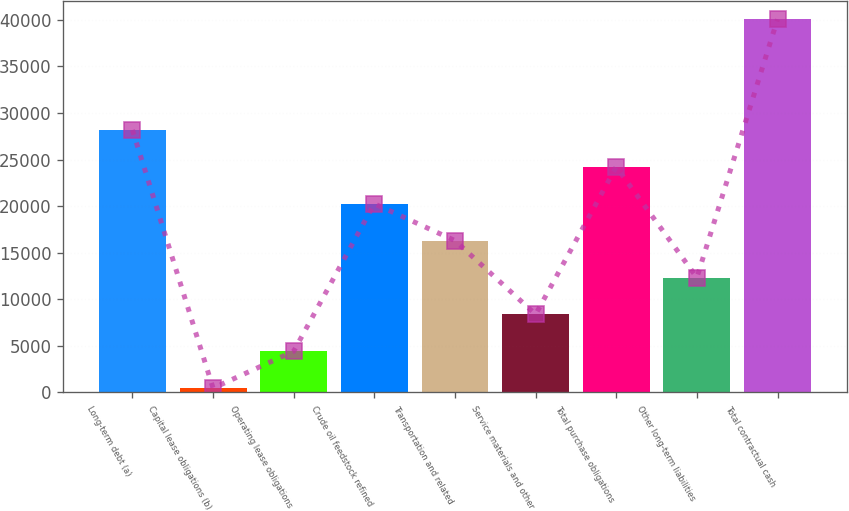Convert chart. <chart><loc_0><loc_0><loc_500><loc_500><bar_chart><fcel>Long-term debt (a)<fcel>Capital lease obligations (b)<fcel>Operating lease obligations<fcel>Crude oil feedstock refined<fcel>Transportation and related<fcel>Service materials and other<fcel>Total purchase obligations<fcel>Other long-term liabilities<fcel>Total contractual cash<nl><fcel>28174.2<fcel>457<fcel>4416.6<fcel>20255<fcel>16295.4<fcel>8376.2<fcel>24214.6<fcel>12335.8<fcel>40053<nl></chart> 